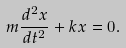<formula> <loc_0><loc_0><loc_500><loc_500>m \frac { d ^ { 2 } x } { d t ^ { 2 } } + k x = 0 .</formula> 